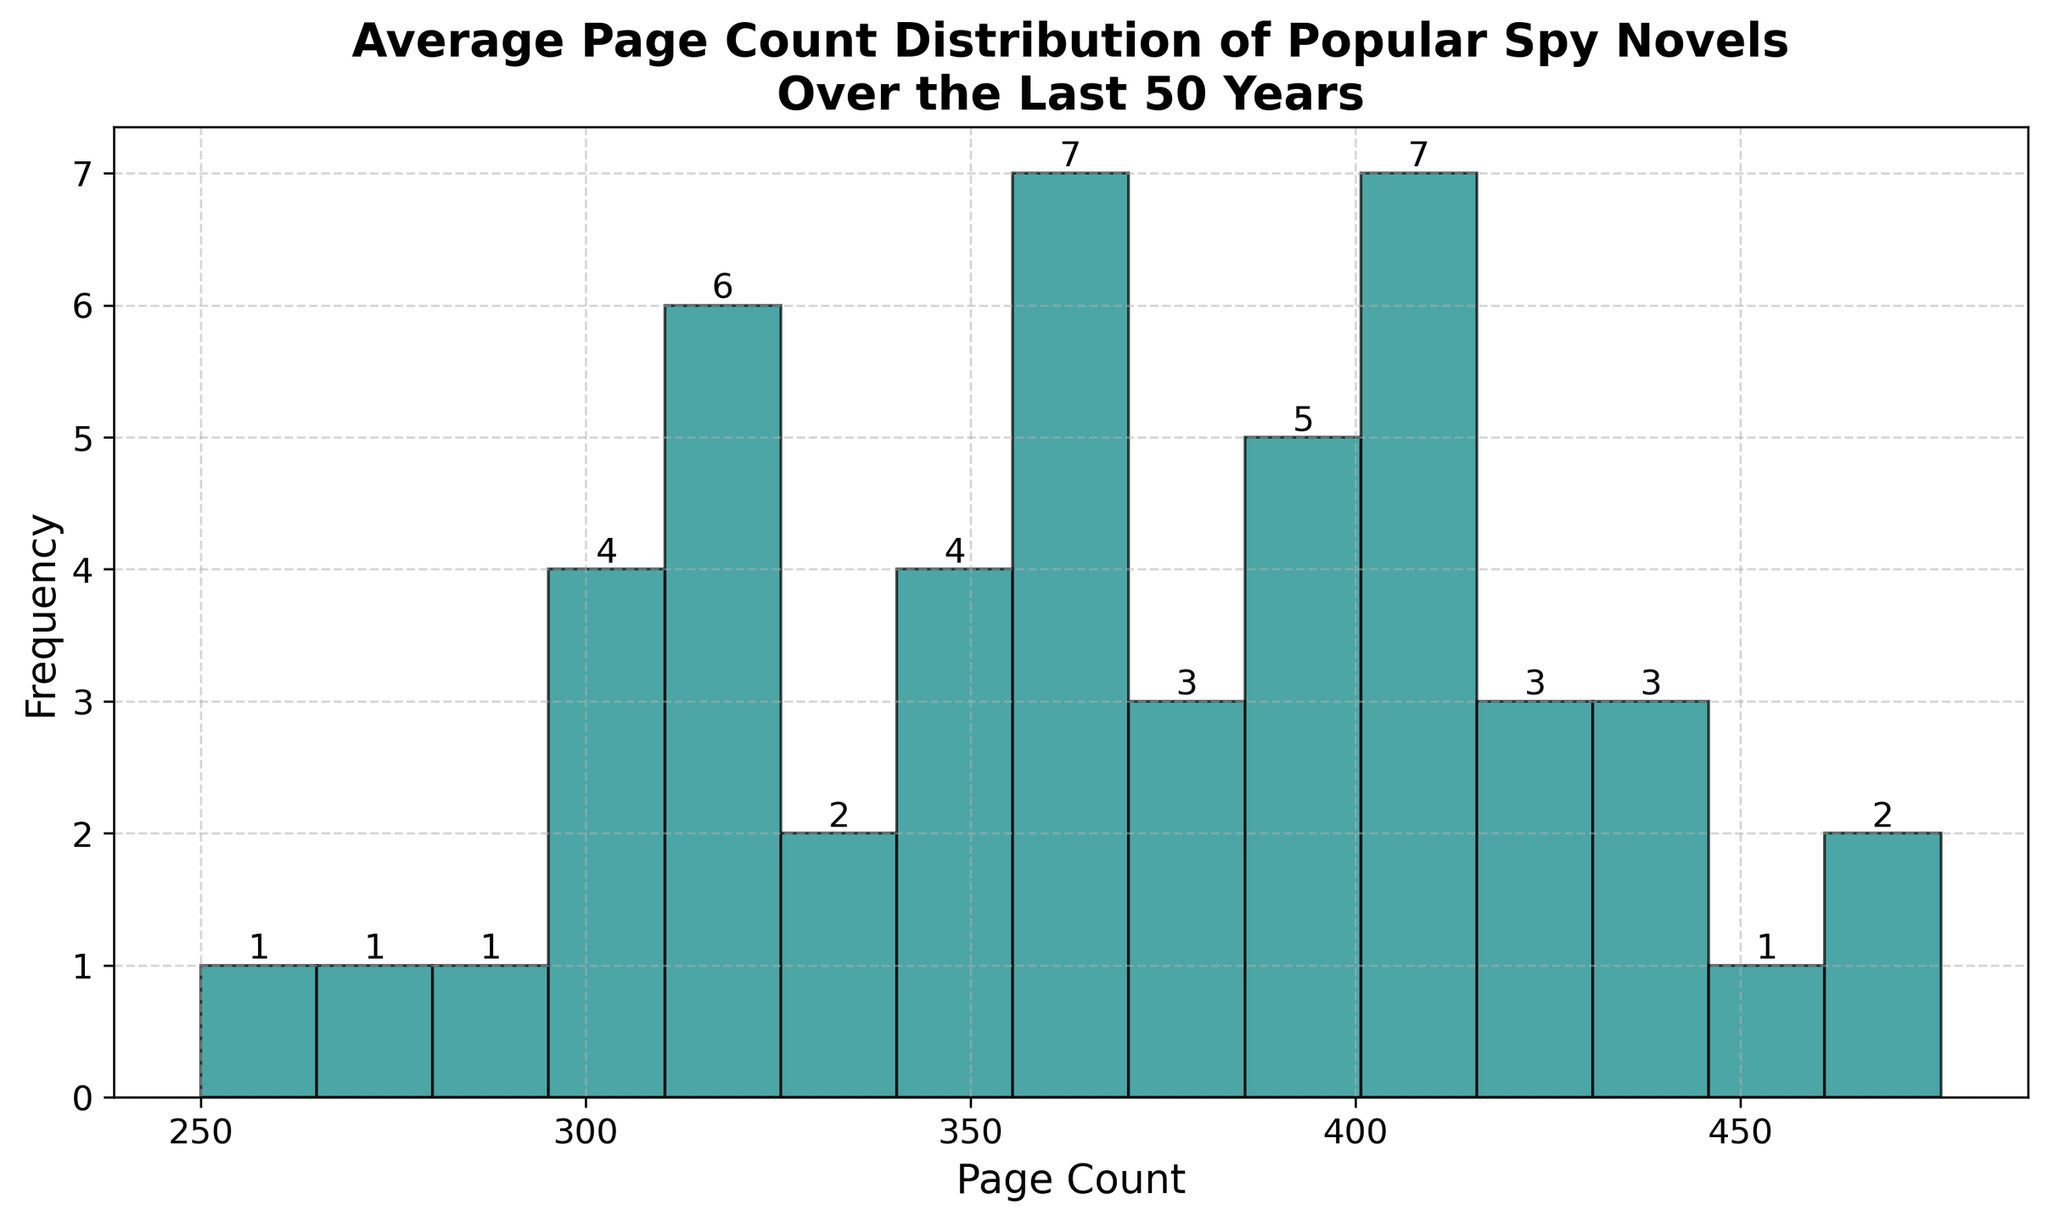What is the most common page count range for the spy novels? The tallest bar in the histogram corresponds to the range of page counts with the highest frequency, which represents the most common page count range. This is visually identified as the range with the highest bar height.
Answer: 320-350 pages How many spy novels have a page count between 320 and 350? Look at the bar corresponding to the 320-350 range, and identify the frequency (height) of this bar. The text at the top of the bar shows the number of novels in this range.
Answer: 8 novels Which decade had more novels with a page count above 400, the 1980s or the 2000s? Identify the bars representing page counts above 400. Then check the individual years in the data. Count how many entries from each decade fall into these bars' ranges. For the 1980s: 1981, 1987, and 1985. For the 2000s: 2004, 2005, 2006, 2007 and 2010.
Answer: 2000s What is the least frequent page count range for the spy novels? Look for the shortest bar in the histogram, which represents the page count range with the least frequency. This can be identified by observing the bar with the lowest height.
Answer: 250-280 pages Are there any page count ranges that have the same frequency? Compare the heights of the bars in the histogram visually. Check for bars that appear to be of the same height and have the same text showing their frequency. The text at the top of the bars will confirm the frequency.
Answer: Yes, two ranges have a frequency of 3 What is the total number of spy novels included in the histogram? Sum all the frequencies indicated by the text at the top of each bar. This requires adding all the numbers together to get the total count.
Answer: 50 novels What page count range contains the median number of pages? Identify the median value from the dataset. Since there are 50 novels, the median will be the average of the 25th and 26th values when the data is ordered. The histogram helps identify the range with the median by finding the cumulative count up to those positions.
Answer: 360-390 pages Which page count range has the highest frequency, and how many novels fall in that range? Find the highest bar in the histogram and read the number at the top of this bar. The height of the bar determines the range with the highest frequency and the number at the top indicates the count.
Answer: 320-350 pages; 8 novels 